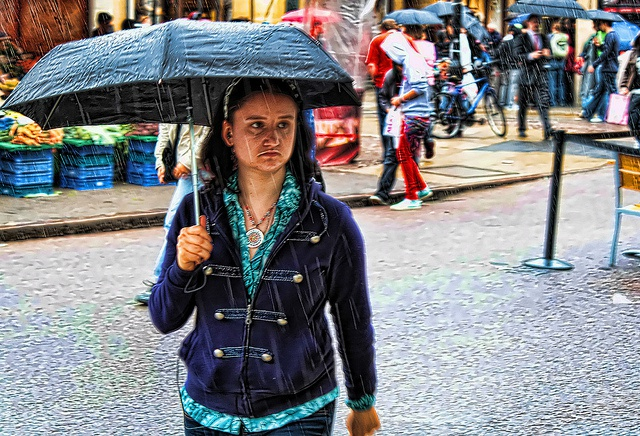Describe the objects in this image and their specific colors. I can see people in brown, black, navy, and tan tones, umbrella in brown, black, gray, and white tones, people in brown, white, black, and maroon tones, people in brown, white, black, darkgray, and lightblue tones, and bicycle in brown, black, white, gray, and darkgray tones in this image. 